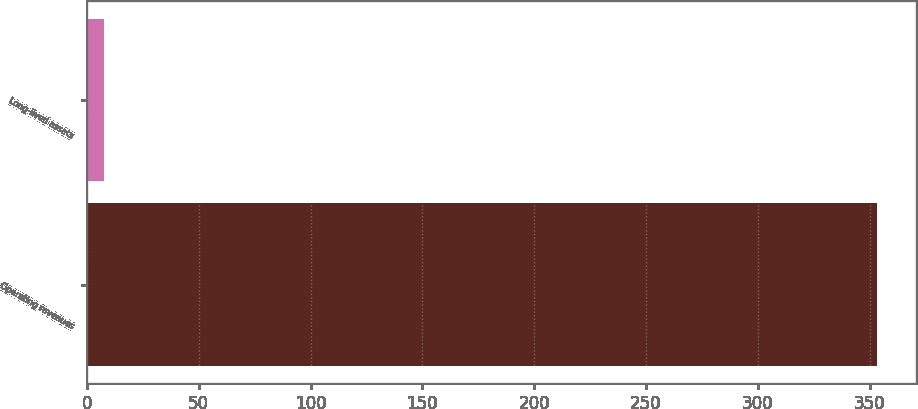<chart> <loc_0><loc_0><loc_500><loc_500><bar_chart><fcel>Operating revenues<fcel>Long-lived assets<nl><fcel>353.1<fcel>7.7<nl></chart> 